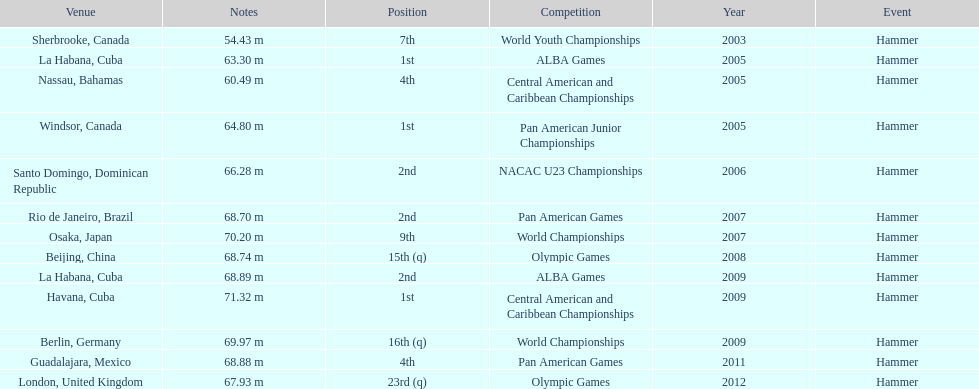Does arasay thondike have more/less than 4 1st place tournament finishes? Less. 